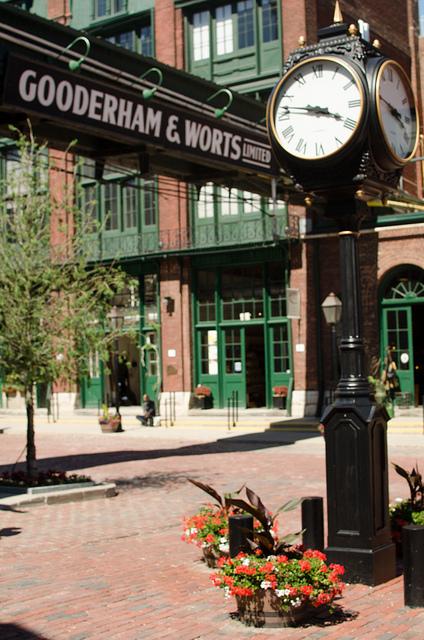What is the material on the ground?
Keep it brief. Brick. What time is shown on the clock's?
Quick response, please. 3:45. What color are the clocks' hands?
Be succinct. Black. 